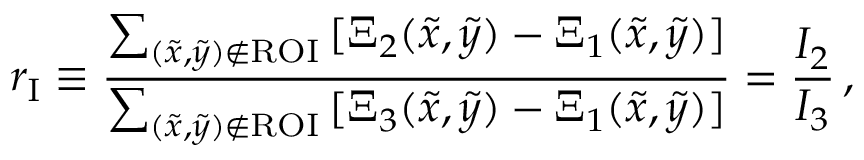<formula> <loc_0><loc_0><loc_500><loc_500>r _ { I } \equiv \frac { \sum _ { ( \tilde { x } , \tilde { y } ) \notin R O I } \, [ \Xi _ { 2 } ( \tilde { x } , \tilde { y } ) - \Xi _ { 1 } ( \tilde { x } , \tilde { y } ) ] } { \sum _ { ( \tilde { x } , \tilde { y } ) \notin R O I } \, [ \Xi _ { 3 } ( \tilde { x } , \tilde { y } ) - \Xi _ { 1 } ( \tilde { x } , \tilde { y } ) ] } = \frac { I _ { 2 } } { I _ { 3 } } \, ,</formula> 